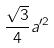Convert formula to latex. <formula><loc_0><loc_0><loc_500><loc_500>\frac { \sqrt { 3 } } { 4 } a ^ { \prime 2 }</formula> 